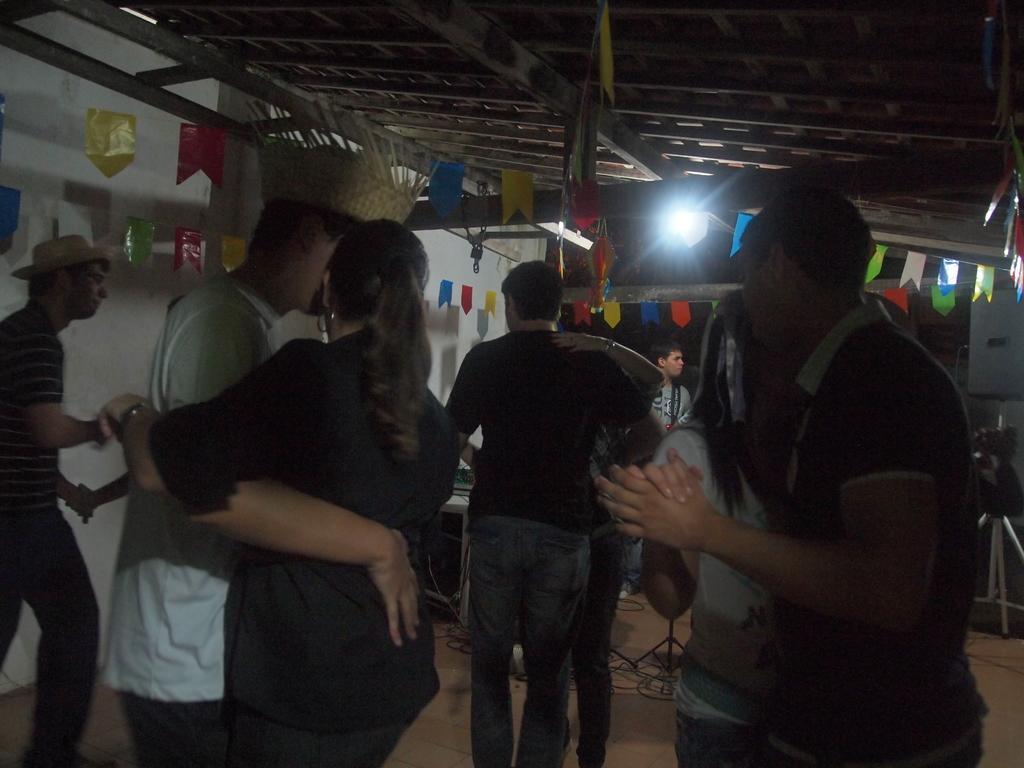Could you give a brief overview of what you see in this image? Here we can see few persons on the floor. In the background we can see wall, flags, and a light. 